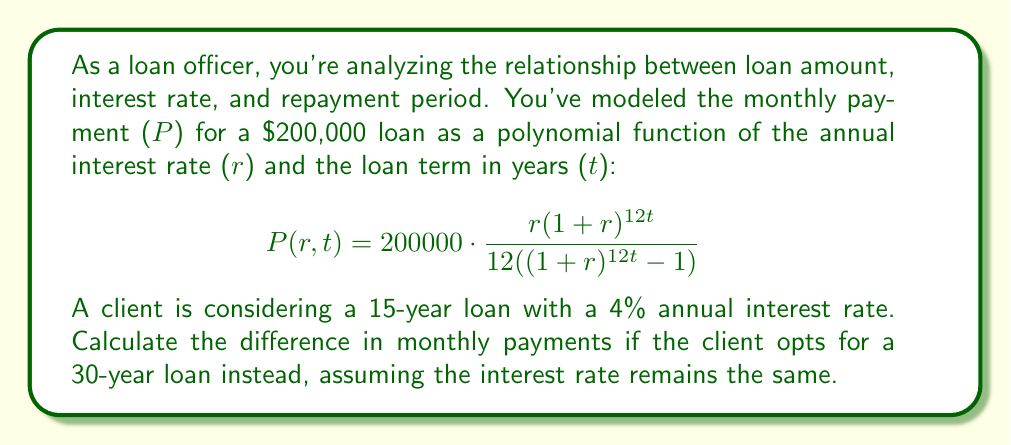Can you answer this question? Let's approach this step-by-step:

1) We need to calculate P(r,t) for two scenarios:
   a) 15-year loan: r = 0.04, t = 15
   b) 30-year loan: r = 0.04, t = 30

2) For the 15-year loan:
   $$P(0.04,15) = 200000 \cdot \frac{0.04(1+0.04)^{12(15)}}{12((1+0.04)^{12(15)}-1)}$$
   
   $$= 200000 \cdot \frac{0.04(1.04)^{180}}{12((1.04)^{180}-1)}$$
   
   $$\approx 1479.38$$

3) For the 30-year loan:
   $$P(0.04,30) = 200000 \cdot \frac{0.04(1+0.04)^{12(30)}}{12((1+0.04)^{12(30)}-1)}$$
   
   $$= 200000 \cdot \frac{0.04(1.04)^{360}}{12((1.04)^{360}-1)}$$
   
   $$\approx 954.83$$

4) The difference in monthly payments:
   $$1479.38 - 954.83 = 524.55$$

Therefore, the client would pay $524.55 less per month with a 30-year loan compared to a 15-year loan.
Answer: $524.55 